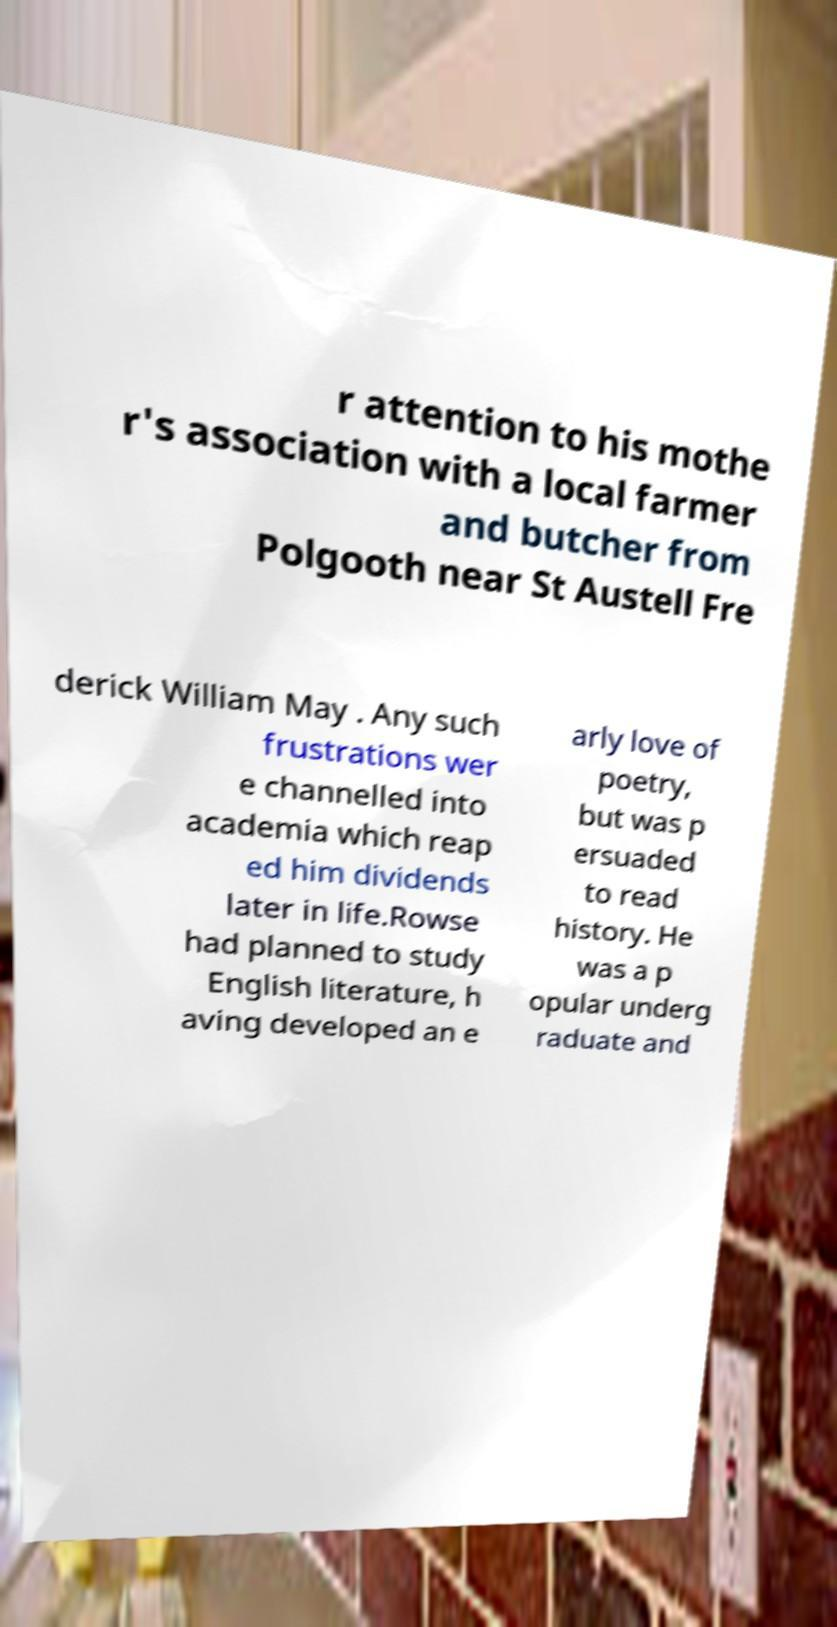Could you extract and type out the text from this image? r attention to his mothe r's association with a local farmer and butcher from Polgooth near St Austell Fre derick William May . Any such frustrations wer e channelled into academia which reap ed him dividends later in life.Rowse had planned to study English literature, h aving developed an e arly love of poetry, but was p ersuaded to read history. He was a p opular underg raduate and 